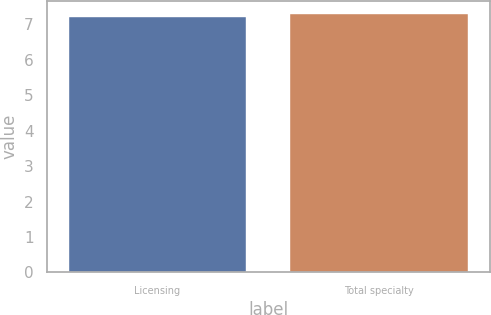Convert chart to OTSL. <chart><loc_0><loc_0><loc_500><loc_500><bar_chart><fcel>Licensing<fcel>Total specialty<nl><fcel>7.2<fcel>7.3<nl></chart> 